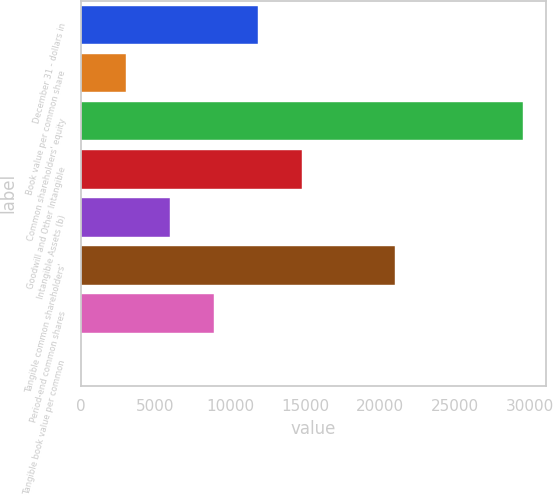Convert chart to OTSL. <chart><loc_0><loc_0><loc_500><loc_500><bar_chart><fcel>December 31 - dollars in<fcel>Book value per common share<fcel>Common shareholders' equity<fcel>Goodwill and Other Intangible<fcel>Intangible Assets (b)<fcel>Tangible common shareholders'<fcel>Period-end common shares<fcel>Tangible book value per common<nl><fcel>11847.9<fcel>2991.89<fcel>29560<fcel>14799.9<fcel>5943.9<fcel>20969<fcel>8895.91<fcel>39.88<nl></chart> 